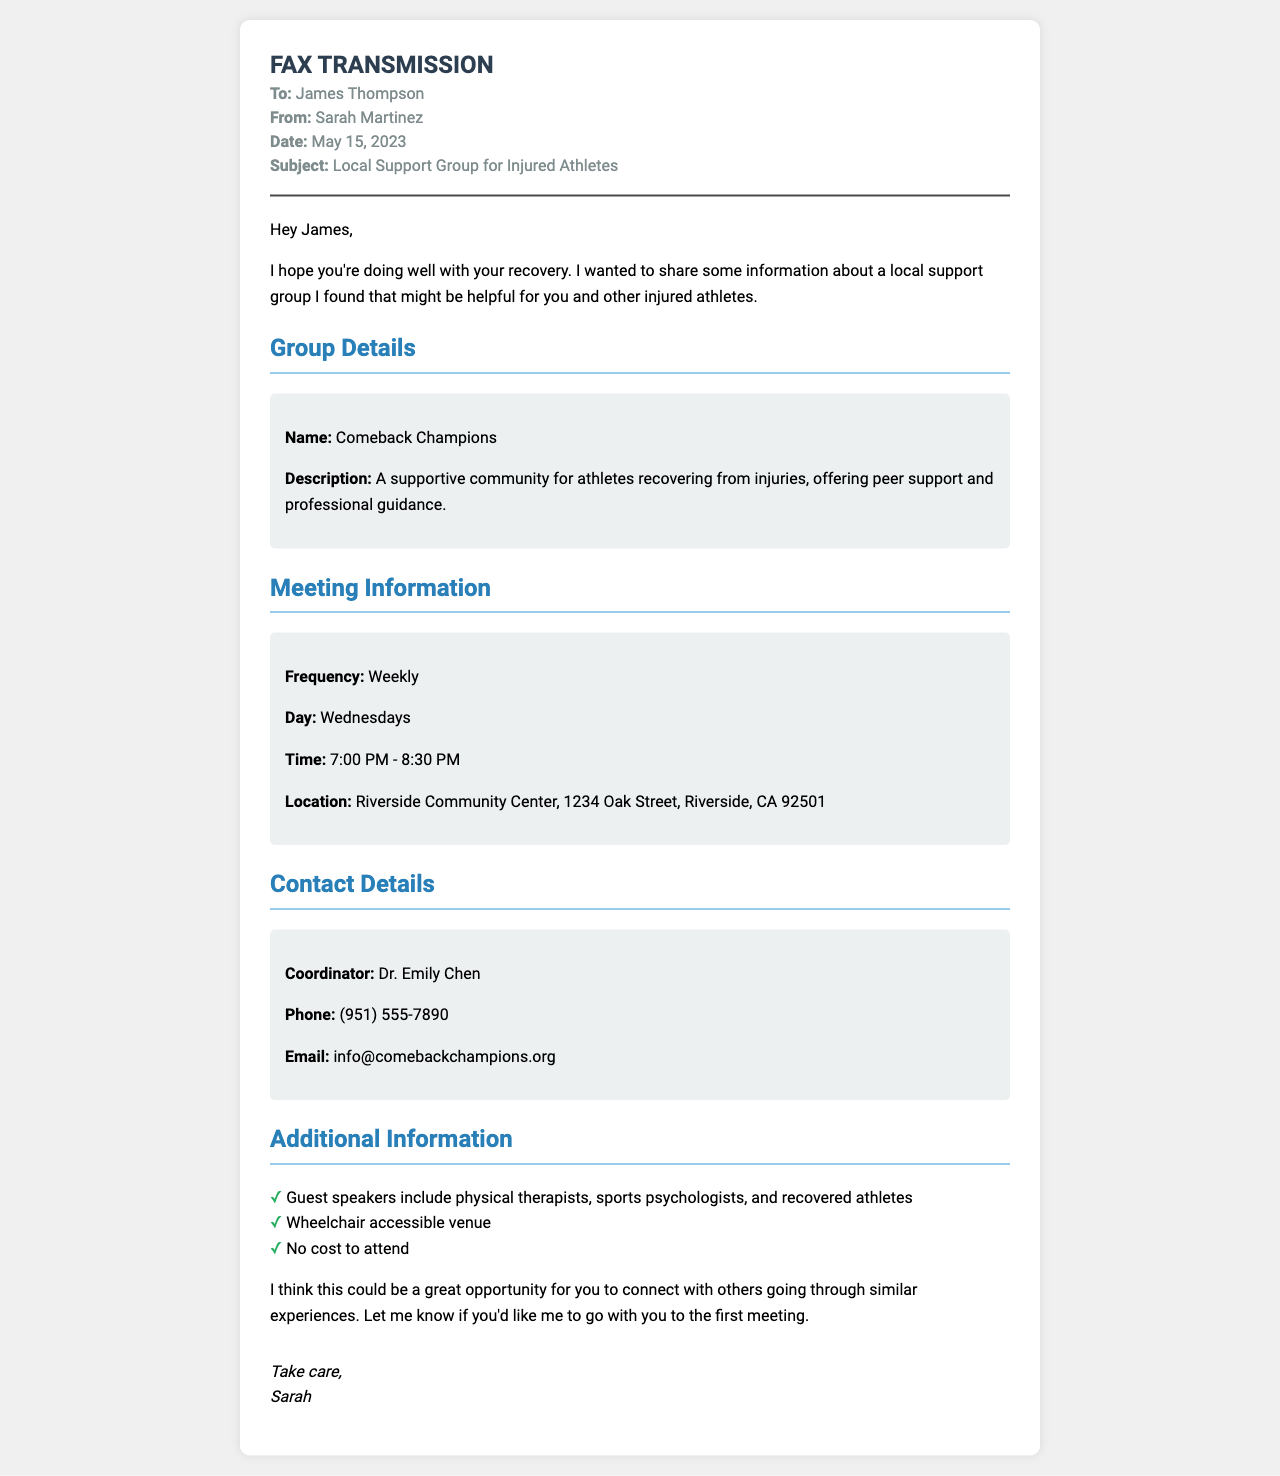What is the name of the support group? The support group's name is explicitly mentioned in the document.
Answer: Comeback Champions When does the support group meet? The document provides specific information about the day of the meetings.
Answer: Wednesdays What time do the meetings start? The starting time for the meetings is detailed in the document.
Answer: 7:00 PM Who is the coordinator of the support group? The document states the name of the individual overseeing the group.
Answer: Dr. Emily Chen Is there a cost to attend the meetings? The document clearly states if there is any cost associated with attending the meetings.
Answer: No cost What is the location of the meetings? The address for the meeting location is provided in the document.
Answer: Riverside Community Center, 1234 Oak Street, Riverside, CA 92501 What types of professionals are invited as guest speakers? The document lists the types of guest speakers that attendees can expect.
Answer: Physical therapists, sports psychologists, and recovered athletes How often do the meetings occur? The frequency of the meetings is specified in the document.
Answer: Weekly Is the venue wheelchair accessible? The document includes information about the accessibility of the meeting venue.
Answer: Yes 